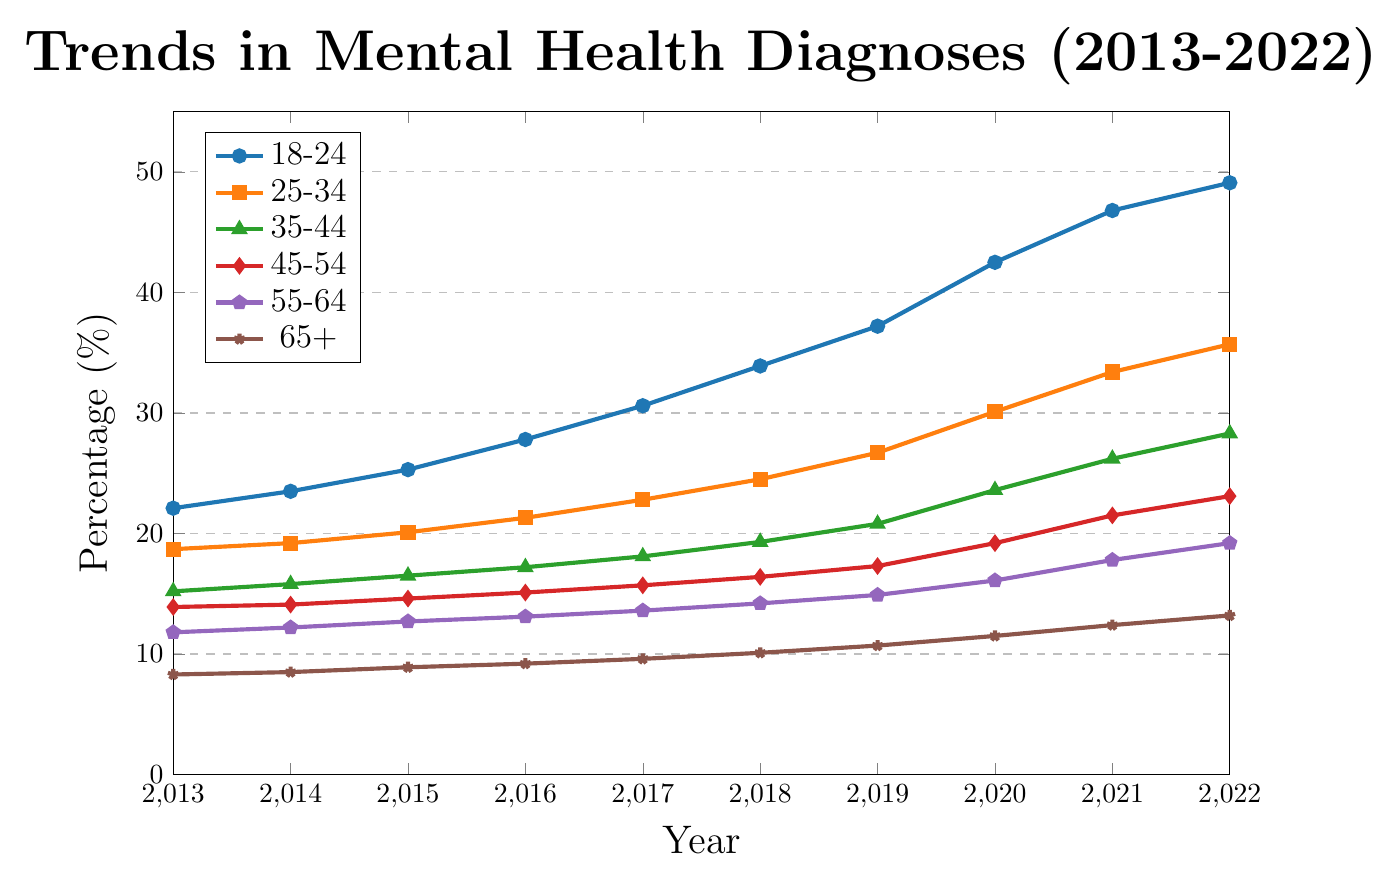What was the percentage of mental health diagnoses for the 18-24 age group in 2018? Look at the data points on the y-axis for the 18-24 age group, which is represented by the blue line marking the year 2018.
Answer: 33.9% Which age group had the highest percentage of mental health diagnoses in 2022? Identify the data points for 2022 and compare the heights of the lines representing different age groups. The 18-24 age group has the highest value.
Answer: 18-24 What is the difference in the percentage of mental health diagnoses between the 45-54 and 65+ age groups in 2019? Look at the y-values for the 45-54 age group and the 65+ age group in 2019. Subtract the value for the 65+ group from the value for the 45-54 group. (17.3 - 10.7)
Answer: 6.6 Which age group saw the largest increase in mental health diagnoses from 2013 to 2022? Calculate the difference between the 2013 and 2022 values for each age group. The 18-24 age group increased from 22.1 to 49.1, which is the largest increase (49.1 - 22.1 = 27).
Answer: 18-24 Was the trend of mental health diagnoses increasing or decreasing for all age groups from 2013 to 2022? Check the direction of the lines for all age groups from 2013 to 2022. All lines are trending upwards, indicating an increase.
Answer: Increasing In 2020, which age group's percentage of mental health diagnoses was closest to 20%? Compare the 2020 data points to find which age group's value is nearest to 20%. The 35-44 age group had a value of 23.6, which is the closest.
Answer: 35-44 What is the average percentage of mental health diagnoses for the 55-64 age group from 2013 to 2022? Sum the percentages of diagnoses for the 55-64 age group from 2013 to 2022 and divide by the number of years (10). Sum = 11.8 + 12.2 + 12.7 + 13.1 + 13.6 + 14.2 + 14.9 + 16.1 + 17.8 + 19.2 = 145.6. Average = 145.6 / 10 = 14.56
Answer: 14.56 How does the percentage of mental health diagnoses for the 25-34 age group in 2014 compare to its percentage in 2018? Look at the y-values for the 25-34 age group in 2014 and 2018. In 2014, it is 19.2%, and in 2018, it is 24.5%. Calculate the difference (24.5 - 19.2).
Answer: 5.3 Between 2013 and 2022, did any age group ever have a lower percentage than 10%? If so, which age group and year? Check the y-values for all age groups each year. The 65+ age group had values below 10% from 2013 to 2018.
Answer: 65+ (2013-2018) 